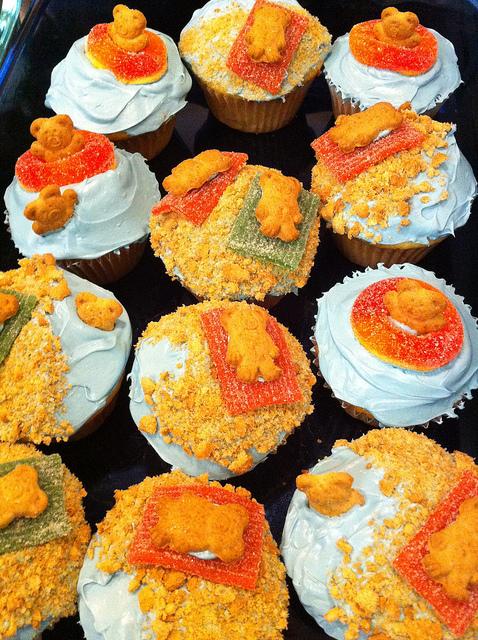How many cupcakes are there?
Keep it brief. 12. How many cupcakes are in this scene?
Be succinct. 12. What kind of toppings are on the cupcakes?
Short answer required. Teddy grahams. 